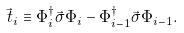<formula> <loc_0><loc_0><loc_500><loc_500>\vec { \, t } _ { i } \equiv \Phi _ { i } ^ { \dag } \vec { \sigma } \Phi _ { i } - \Phi _ { i - 1 } ^ { \dag } \vec { \sigma } \Phi _ { i - 1 } .</formula> 